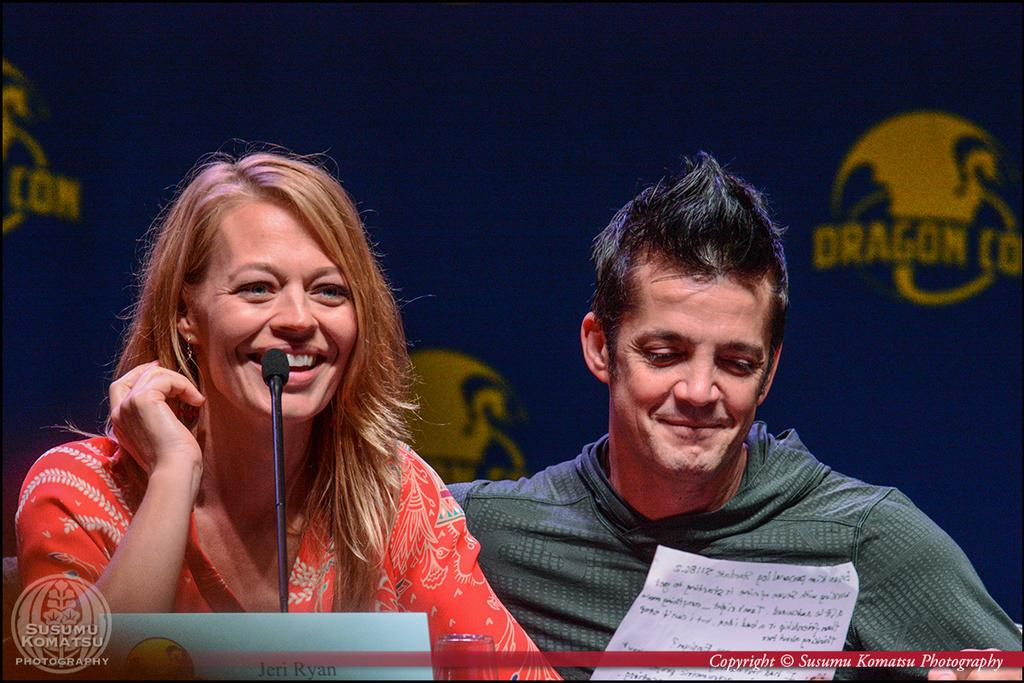What object is located in the middle of the image? There is a microphone, a glass, and a paper in the middle of the image. What are the two persons in the image doing? The two persons are sitting and smiling in the image. What can be seen at the top of the image? There is a banner at the top of the image. What type of furniture is visible in the image? There is no furniture present in the image. Can you see a ship in the image? There is no ship present in the image. 